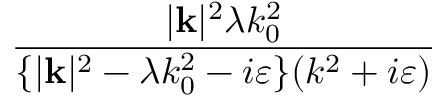Convert formula to latex. <formula><loc_0><loc_0><loc_500><loc_500>\frac { | k | ^ { 2 } \lambda k _ { 0 } ^ { 2 } } { \{ | k | ^ { 2 } - \lambda k _ { 0 } ^ { 2 } - i \varepsilon \} ( k ^ { 2 } + i \varepsilon ) }</formula> 